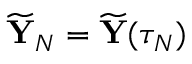Convert formula to latex. <formula><loc_0><loc_0><loc_500><loc_500>\widetilde { \mathbf Y } _ { N } = \widetilde { \mathbf Y } ( \tau _ { N } )</formula> 